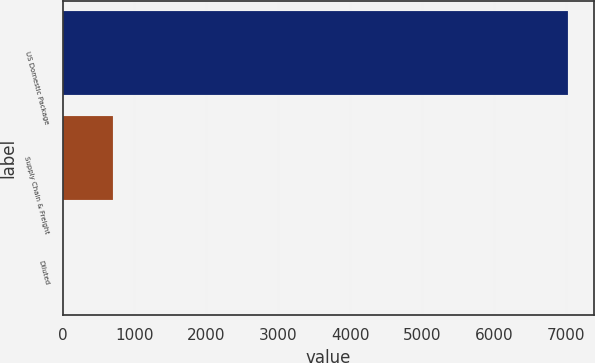Convert chart to OTSL. <chart><loc_0><loc_0><loc_500><loc_500><bar_chart><fcel>US Domestic Package<fcel>Supply Chain & Freight<fcel>Diluted<nl><fcel>7033<fcel>704.07<fcel>0.86<nl></chart> 